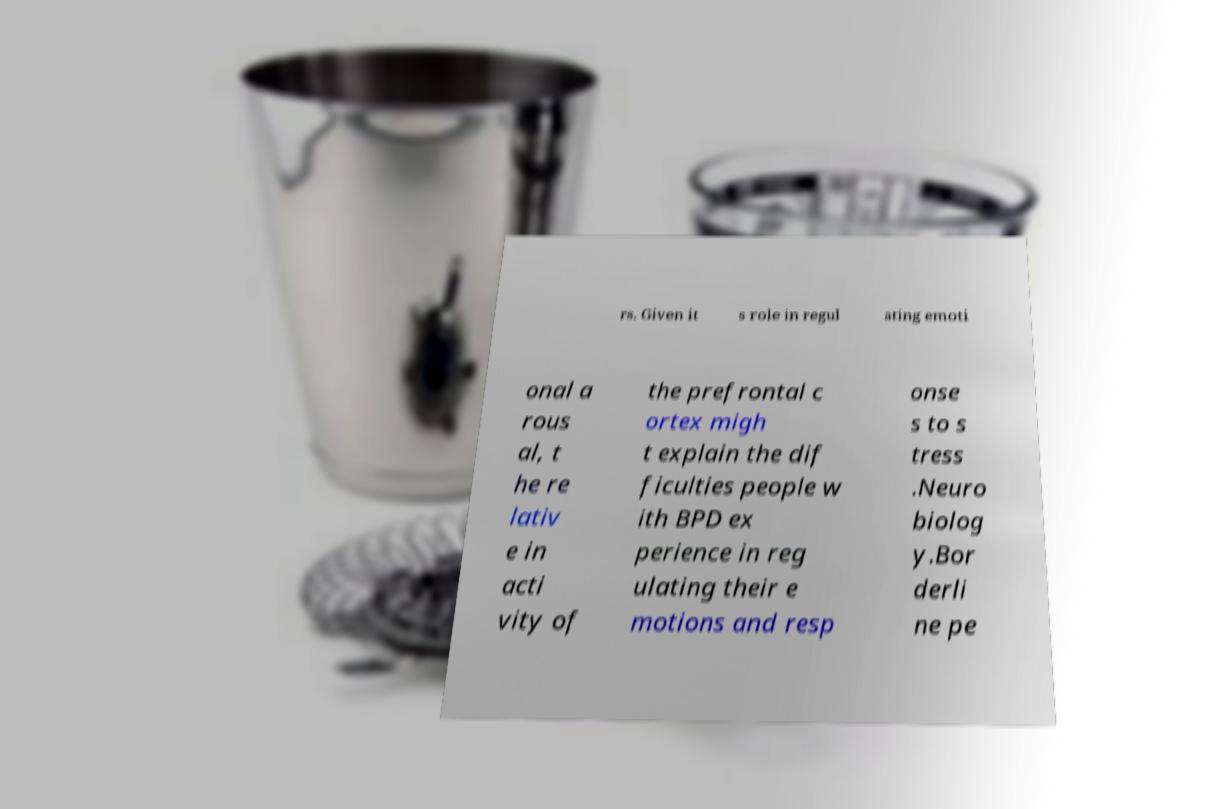Please identify and transcribe the text found in this image. rs. Given it s role in regul ating emoti onal a rous al, t he re lativ e in acti vity of the prefrontal c ortex migh t explain the dif ficulties people w ith BPD ex perience in reg ulating their e motions and resp onse s to s tress .Neuro biolog y.Bor derli ne pe 